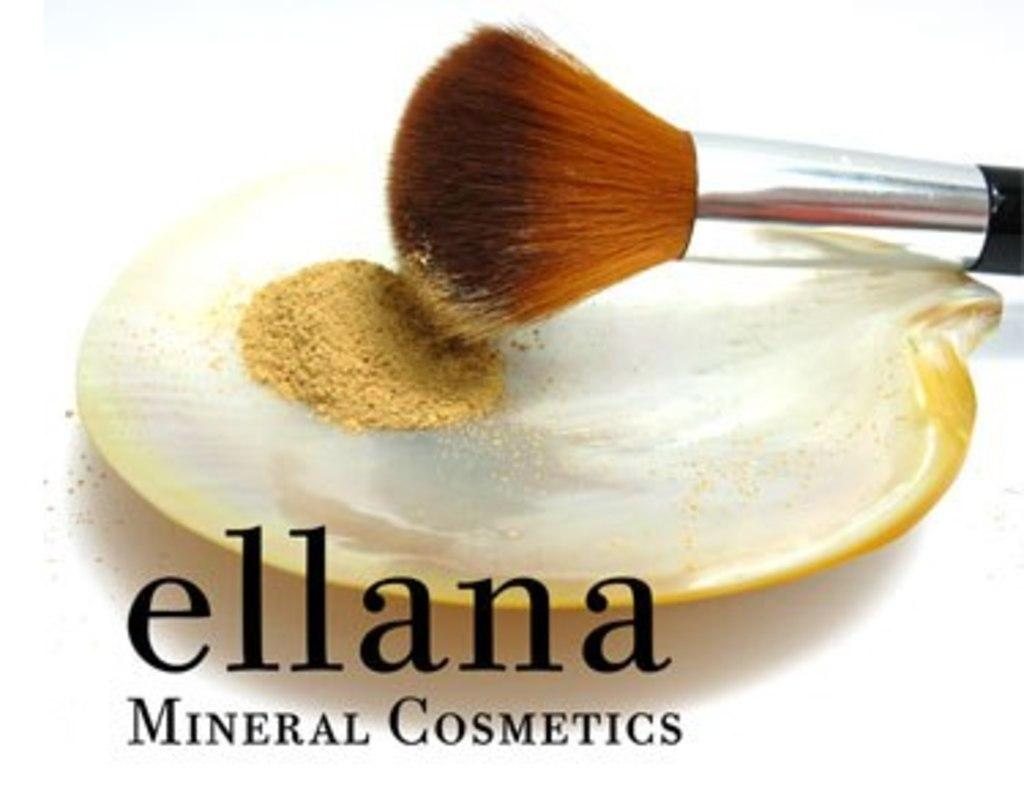Provide a one-sentence caption for the provided image. a makeup brush on a tray with powder that is from ellana mineral cosmetics. 